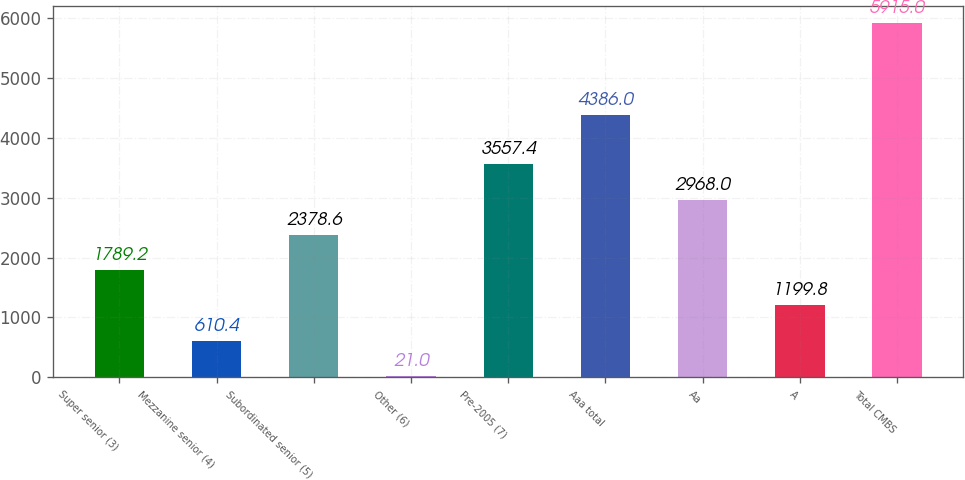<chart> <loc_0><loc_0><loc_500><loc_500><bar_chart><fcel>Super senior (3)<fcel>Mezzanine senior (4)<fcel>Subordinated senior (5)<fcel>Other (6)<fcel>Pre-2005 (7)<fcel>Aaa total<fcel>Aa<fcel>A<fcel>Total CMBS<nl><fcel>1789.2<fcel>610.4<fcel>2378.6<fcel>21<fcel>3557.4<fcel>4386<fcel>2968<fcel>1199.8<fcel>5915<nl></chart> 